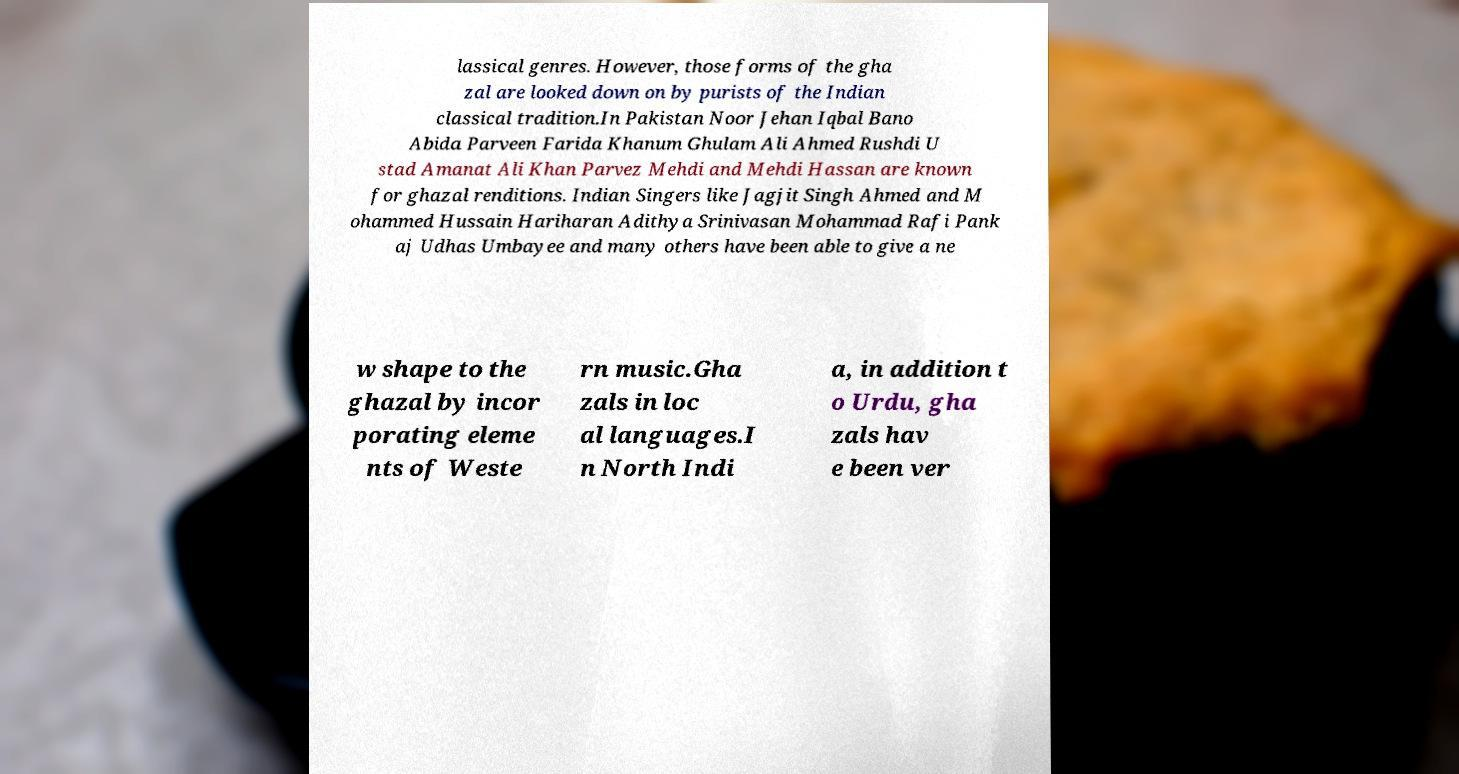What messages or text are displayed in this image? I need them in a readable, typed format. lassical genres. However, those forms of the gha zal are looked down on by purists of the Indian classical tradition.In Pakistan Noor Jehan Iqbal Bano Abida Parveen Farida Khanum Ghulam Ali Ahmed Rushdi U stad Amanat Ali Khan Parvez Mehdi and Mehdi Hassan are known for ghazal renditions. Indian Singers like Jagjit Singh Ahmed and M ohammed Hussain Hariharan Adithya Srinivasan Mohammad Rafi Pank aj Udhas Umbayee and many others have been able to give a ne w shape to the ghazal by incor porating eleme nts of Weste rn music.Gha zals in loc al languages.I n North Indi a, in addition t o Urdu, gha zals hav e been ver 